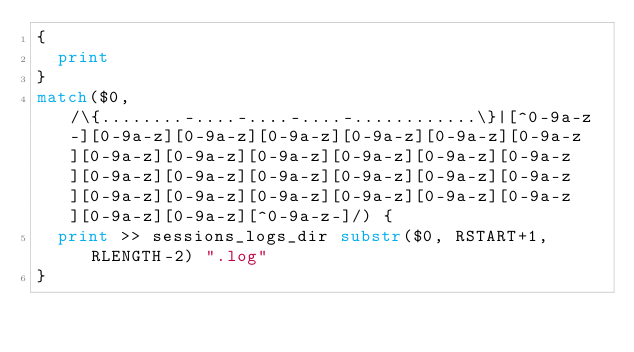<code> <loc_0><loc_0><loc_500><loc_500><_Awk_>{
	print
}
match($0, /\{........-....-....-....-............\}|[^0-9a-z-][0-9a-z][0-9a-z][0-9a-z][0-9a-z][0-9a-z][0-9a-z][0-9a-z][0-9a-z][0-9a-z][0-9a-z][0-9a-z][0-9a-z][0-9a-z][0-9a-z][0-9a-z][0-9a-z][0-9a-z][0-9a-z][0-9a-z][0-9a-z][0-9a-z][0-9a-z][0-9a-z][0-9a-z][0-9a-z][0-9a-z][^0-9a-z-]/) {
	print >> sessions_logs_dir substr($0, RSTART+1, RLENGTH-2) ".log"
}</code> 